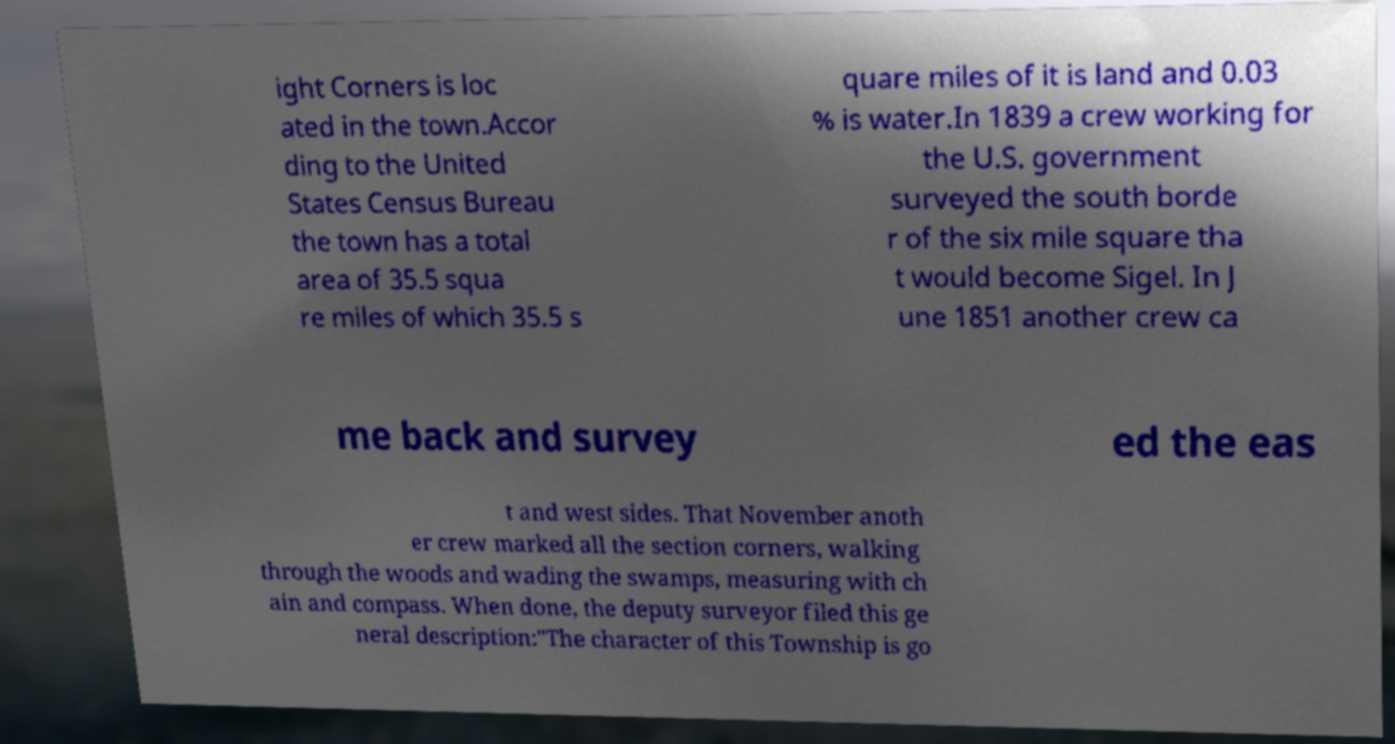Can you accurately transcribe the text from the provided image for me? ight Corners is loc ated in the town.Accor ding to the United States Census Bureau the town has a total area of 35.5 squa re miles of which 35.5 s quare miles of it is land and 0.03 % is water.In 1839 a crew working for the U.S. government surveyed the south borde r of the six mile square tha t would become Sigel. In J une 1851 another crew ca me back and survey ed the eas t and west sides. That November anoth er crew marked all the section corners, walking through the woods and wading the swamps, measuring with ch ain and compass. When done, the deputy surveyor filed this ge neral description:"The character of this Township is go 